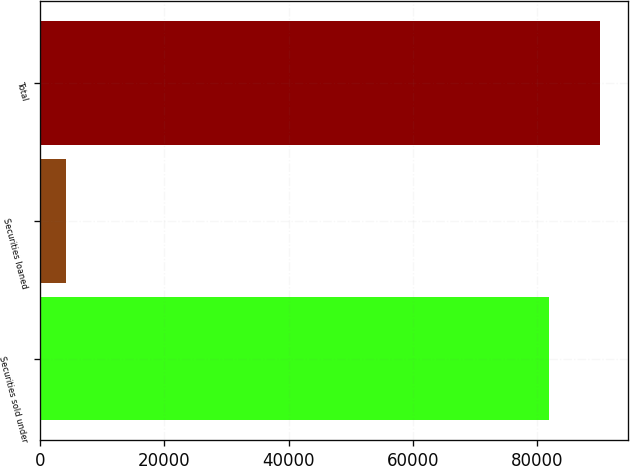Convert chart. <chart><loc_0><loc_0><loc_500><loc_500><bar_chart><fcel>Securities sold under<fcel>Securities loaned<fcel>Total<nl><fcel>81917<fcel>4197<fcel>90108.7<nl></chart> 